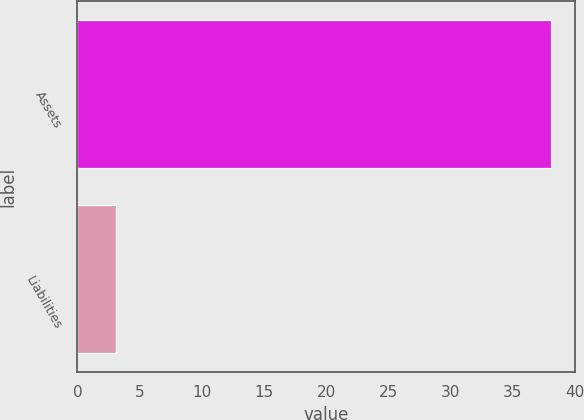Convert chart to OTSL. <chart><loc_0><loc_0><loc_500><loc_500><bar_chart><fcel>Assets<fcel>Liabilities<nl><fcel>38.1<fcel>3.1<nl></chart> 